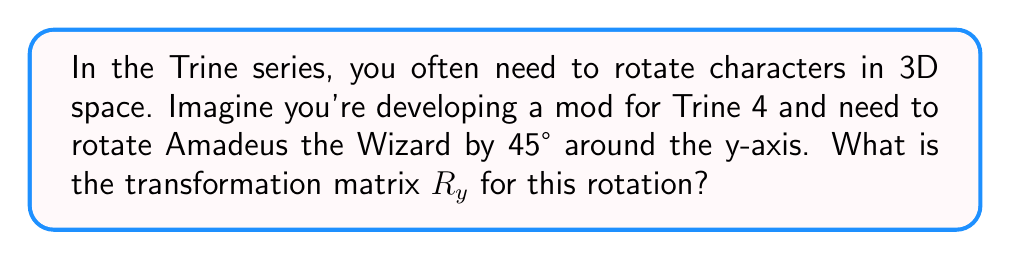Show me your answer to this math problem. To solve this problem, we need to understand the rotation matrix for 3D rotations around the y-axis. In general, the rotation matrix $R_y(\theta)$ for a counterclockwise rotation of $\theta$ radians around the y-axis is:

$$R_y(\theta) = \begin{bmatrix}
\cos(\theta) & 0 & \sin(\theta) \\
0 & 1 & 0 \\
-\sin(\theta) & 0 & \cos(\theta)
\end{bmatrix}$$

For our specific case:
1. We need to rotate by 45°.
2. We need to convert 45° to radians: $45° \times \frac{\pi}{180°} = \frac{\pi}{4}$ radians.

Now, let's substitute $\theta = \frac{\pi}{4}$ into our rotation matrix:

$$R_y(\frac{\pi}{4}) = \begin{bmatrix}
\cos(\frac{\pi}{4}) & 0 & \sin(\frac{\pi}{4}) \\
0 & 1 & 0 \\
-\sin(\frac{\pi}{4}) & 0 & \cos(\frac{\pi}{4})
\end{bmatrix}$$

Recall that $\cos(\frac{\pi}{4}) = \sin(\frac{\pi}{4}) = \frac{\sqrt{2}}{2}$. Substituting these values:

$$R_y(\frac{\pi}{4}) = \begin{bmatrix}
\frac{\sqrt{2}}{2} & 0 & \frac{\sqrt{2}}{2} \\
0 & 1 & 0 \\
-\frac{\sqrt{2}}{2} & 0 & \frac{\sqrt{2}}{2}
\end{bmatrix}$$

This is our final transformation matrix for rotating Amadeus by 45° around the y-axis.
Answer: $$R_y(\frac{\pi}{4}) = \begin{bmatrix}
\frac{\sqrt{2}}{2} & 0 & \frac{\sqrt{2}}{2} \\
0 & 1 & 0 \\
-\frac{\sqrt{2}}{2} & 0 & \frac{\sqrt{2}}{2}
\end{bmatrix}$$ 